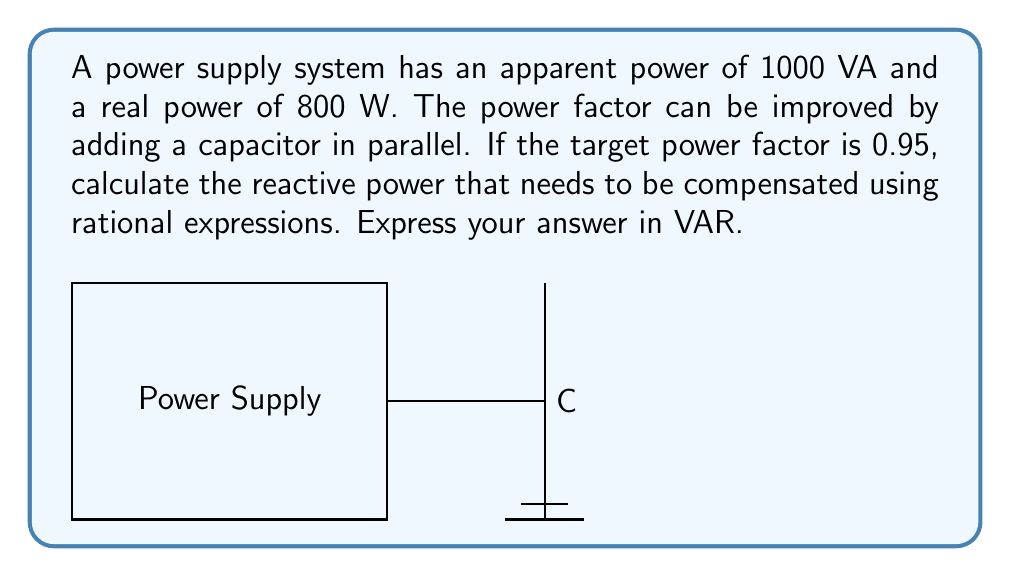Could you help me with this problem? Let's approach this step-by-step using rational expressions:

1) First, calculate the current power factor:
   $PF = \frac{Real Power}{Apparent Power} = \frac{800}{1000} = 0.8$

2) Calculate the current reactive power:
   $Q_1 = \sqrt{S^2 - P^2} = \sqrt{1000^2 - 800^2} = 600$ VAR

3) For the target power factor of 0.95, calculate the new reactive power:
   $Q_2 = P \cdot \tan(\arccos(0.95)) = 800 \cdot \tan(\arccos(0.95)) \approx 262.86$ VAR

4) The reactive power to be compensated is the difference:
   $Q_c = Q_1 - Q_2 = 600 - 262.86 = 337.14$ VAR

5) We can express this as a rational expression:
   $Q_c = \frac{600 \cdot 1000 - 800 \cdot \tan(\arccos(0.95)) \cdot 1000}{1000}$

6) Simplifying:
   $Q_c = \frac{600000 - 800000 \cdot \tan(\arccos(0.95))}{1000}$

7) Evaluating:
   $Q_c \approx 337.14$ VAR
Answer: $\frac{600000 - 800000 \cdot \tan(\arccos(0.95))}{1000} \approx 337.14$ VAR 